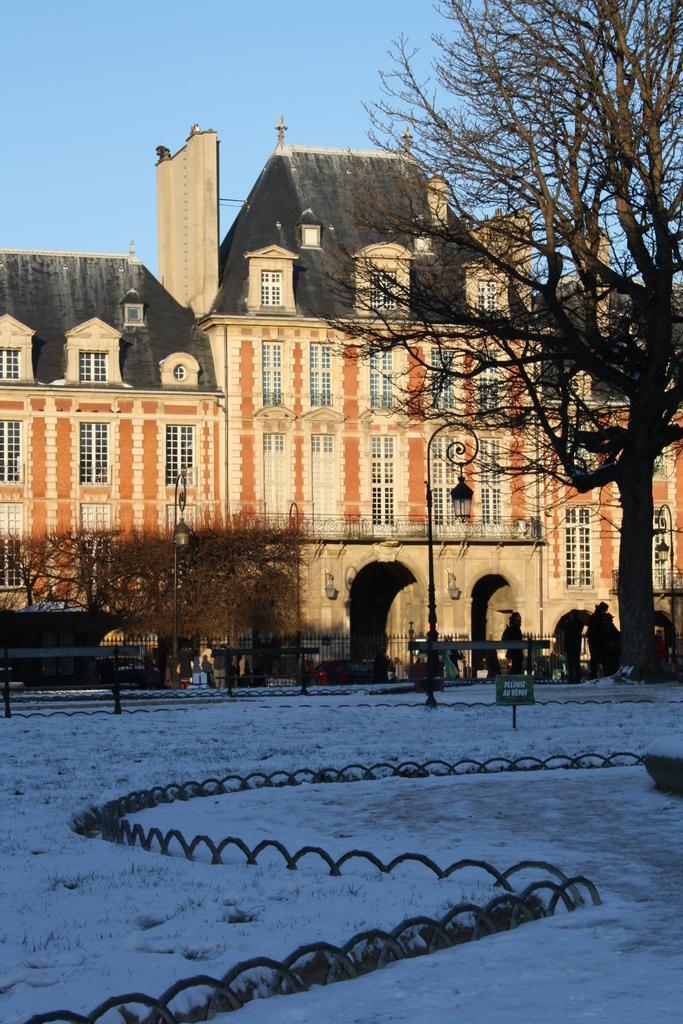Please provide a concise description of this image. In this image we can see a building, windows, light poles, sign board, snow, fencing, plants and tree, there are few persons, also we can see the sky. 